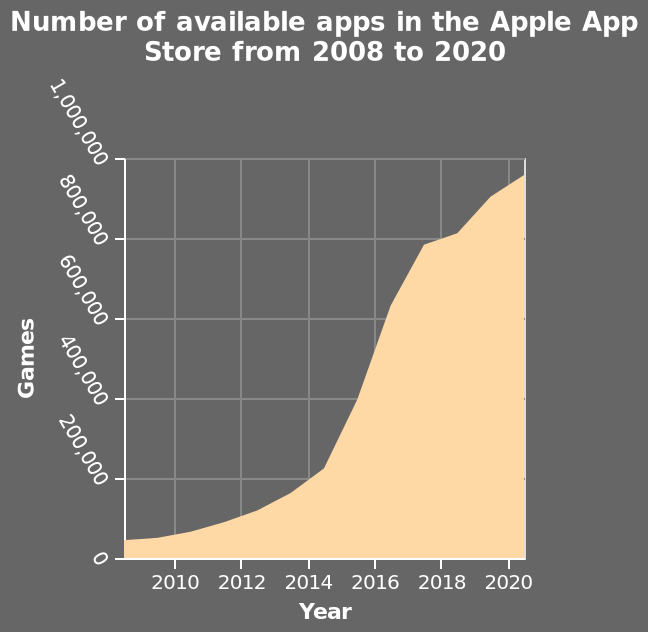<image>
Describe the following image in detail Here a area plot is named Number of available apps in the Apple App Store from 2008 to 2020. The y-axis plots Games while the x-axis plots Year. When did the growth of apps increase again after slowing down? The growth of apps increased again after slowing down during 2017/18. 